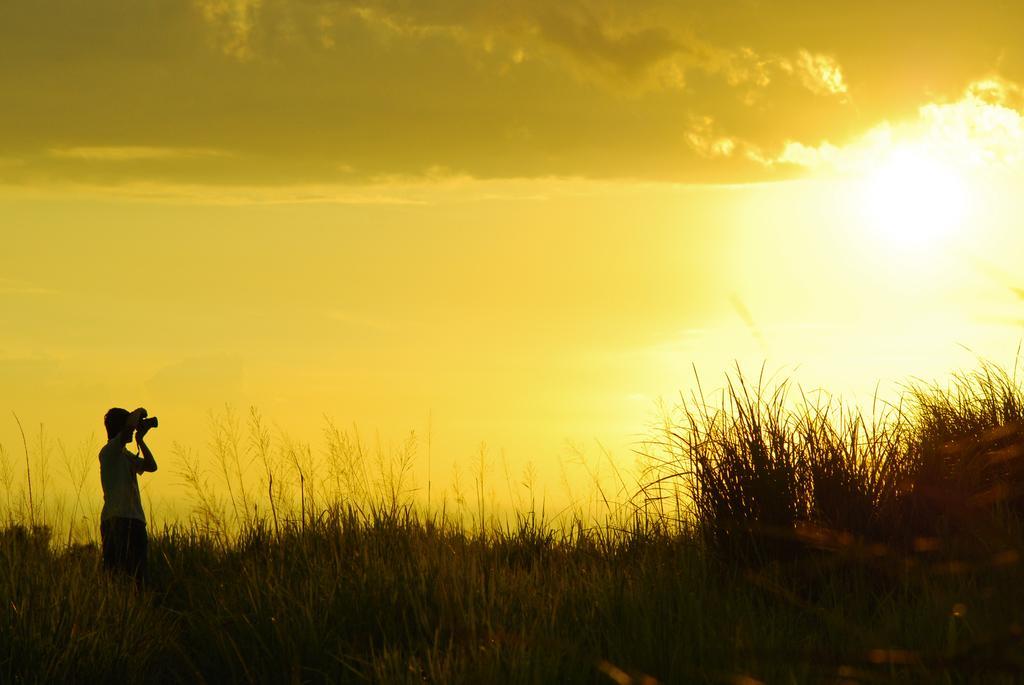In one or two sentences, can you explain what this image depicts? In this picture there is a person standing and holding a camera and we can see grass. In the background of the image we can see the sky with clouds. 